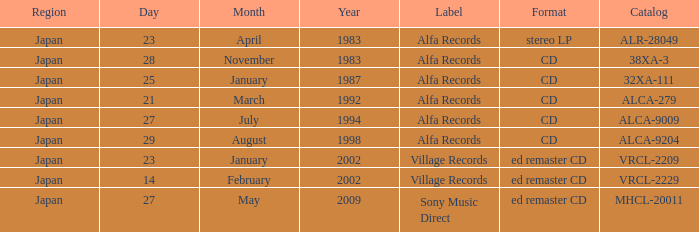What is the format of the date February 14, 2002? Ed remaster cd. 